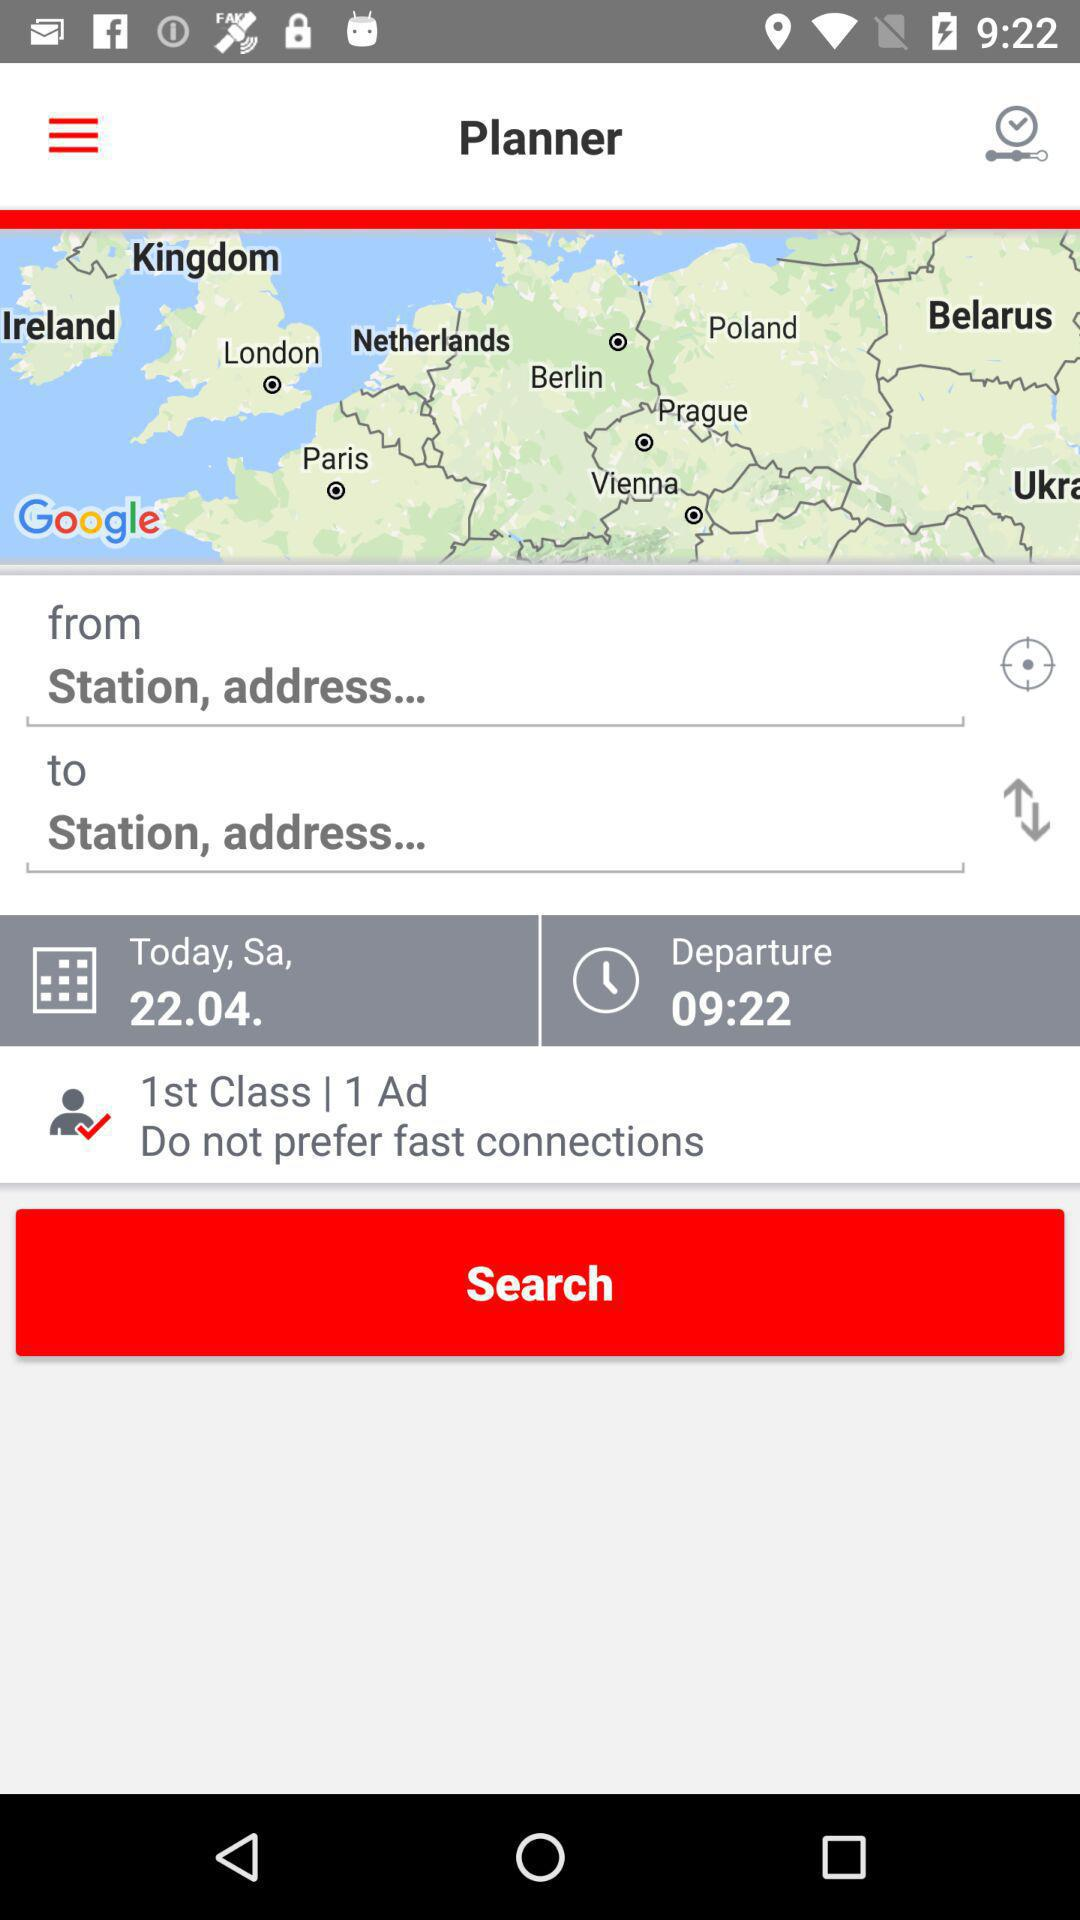How many people are traveling?
Answer the question using a single word or phrase. 1 